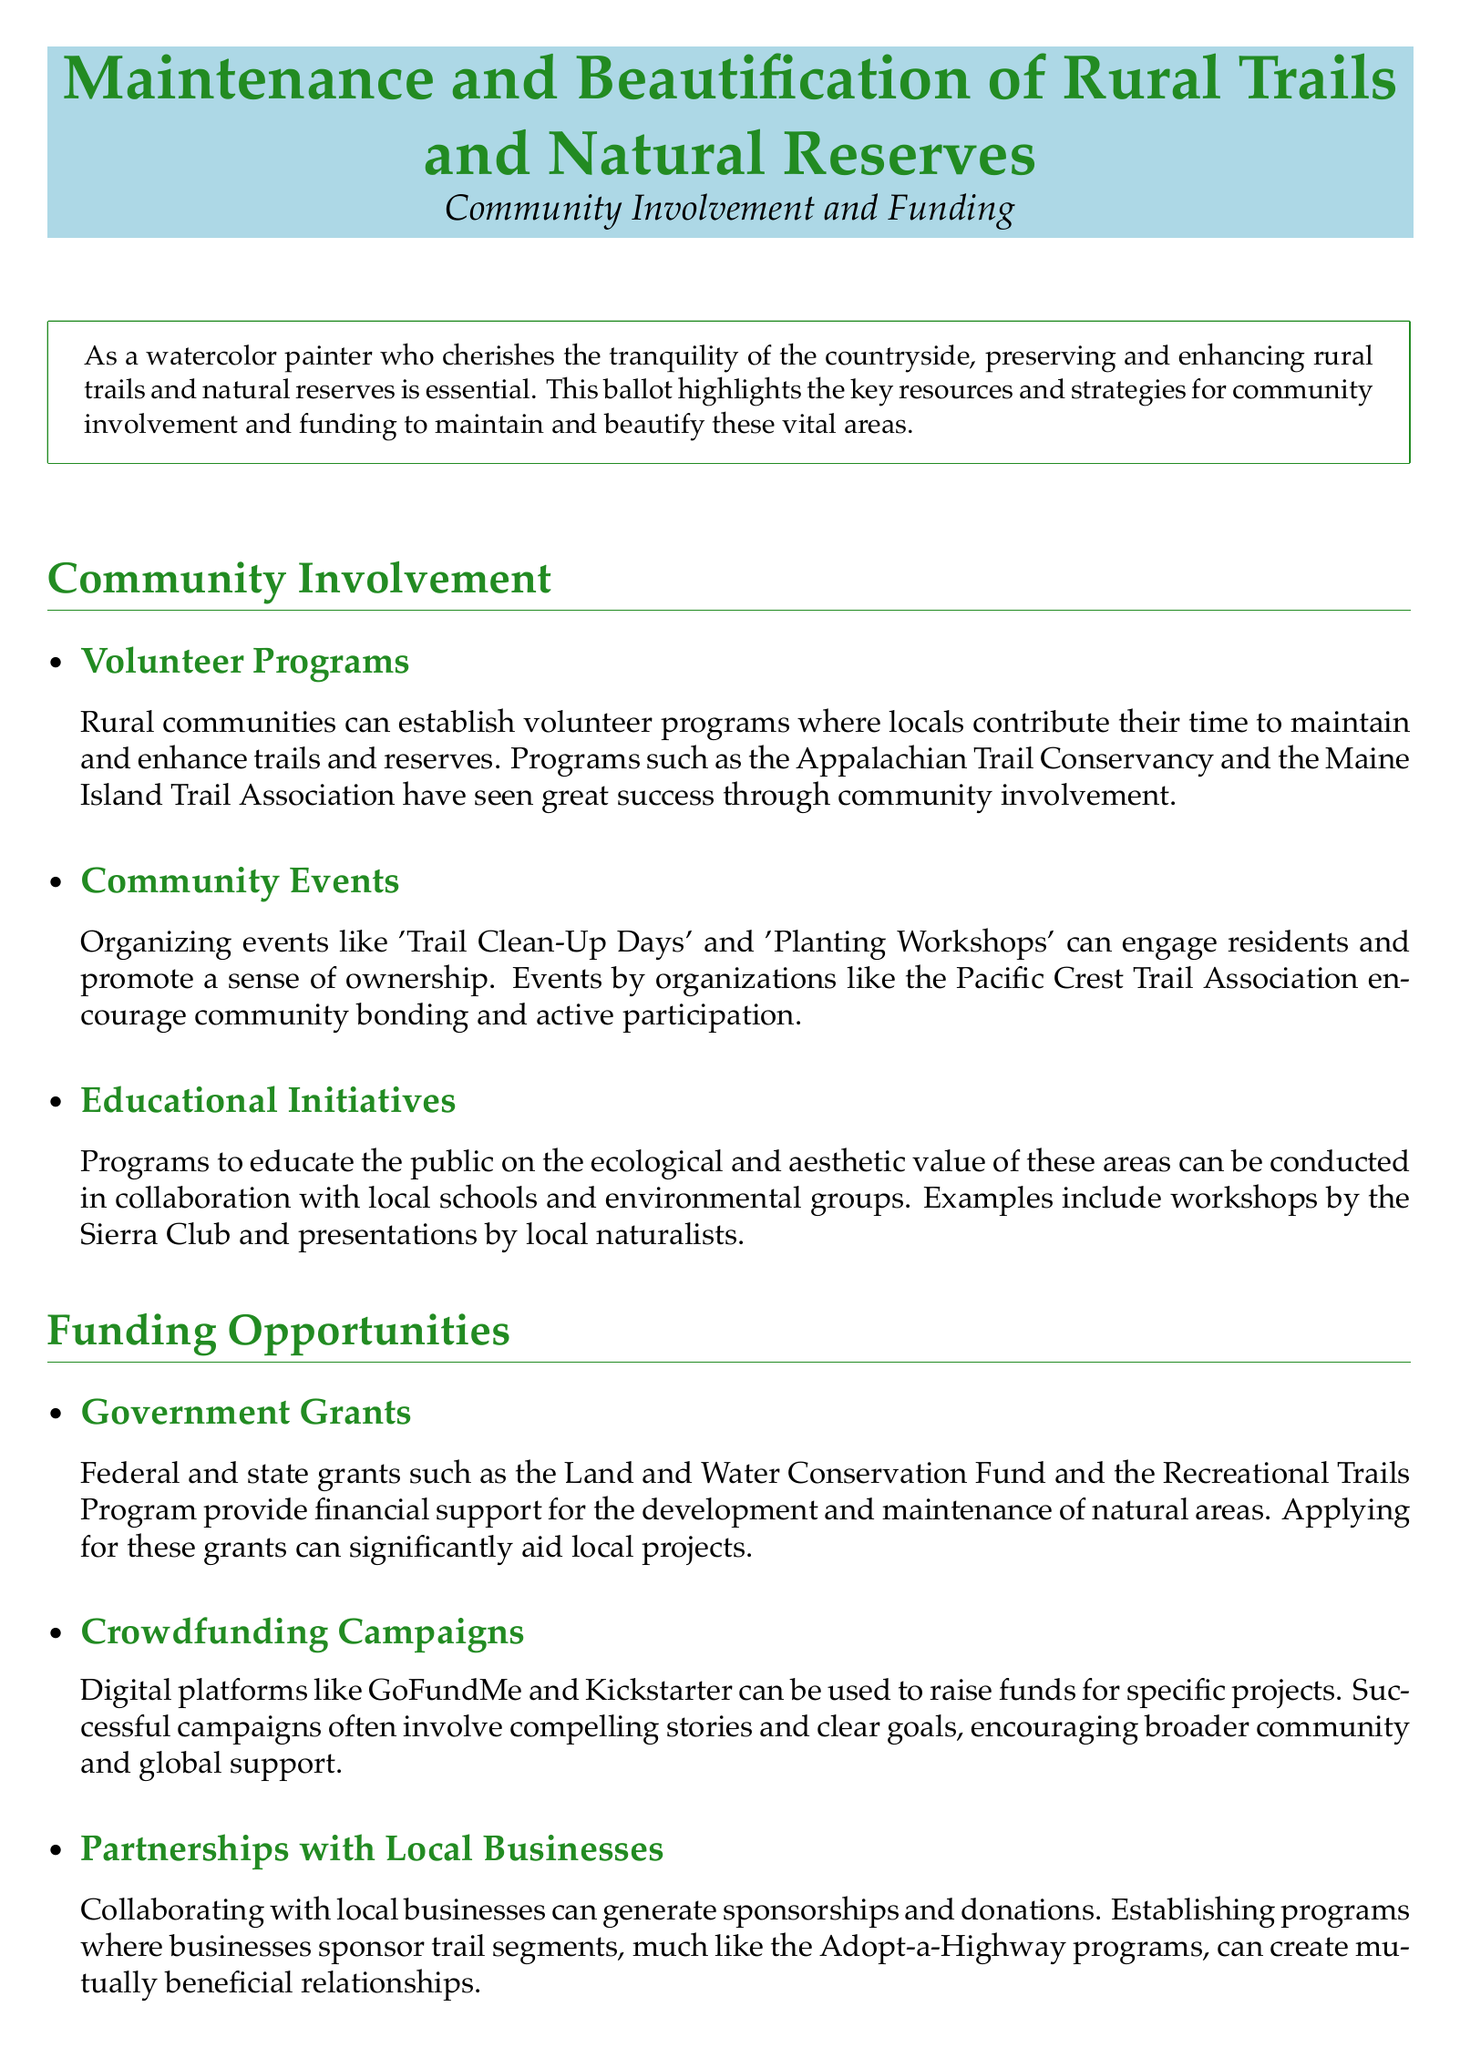What is the title of the document? The title is the main subject of the document and is provided at the beginning.
Answer: Maintenance and Beautification of Rural Trails and Natural Reserves What color is used for section titles? The document specifies a color scheme, and section titles are consistently colored.
Answer: naturegreen What type of programs can locals establish for trail maintenance? The document describes initiatives that engage local community members in upkeep efforts.
Answer: Volunteer Programs Which federal funding source is mentioned? The document lists specific financial support options for maintaining natural areas.
Answer: Land and Water Conservation Fund What educational organization is mentioned for workshops? The document indicates partnerships with local groups for public education on environmental issues.
Answer: Sierra Club What successful crowdfunding platform is mentioned? The document suggests using specific online platforms for fundraising efforts.
Answer: GoFundMe Which natural area effectively combined federal funding with community efforts? The document provides a case study highlighting the successful collaboration of funding and community involvement.
Answer: Muir Woods National Monument What event type encourages community bonding? The document lists specific activities aimed at engaging residents in preservation efforts.
Answer: Planting Workshops How many funding opportunity types are provided? The document outlines various ways to secure funds, directly indicated in the content.
Answer: Three 